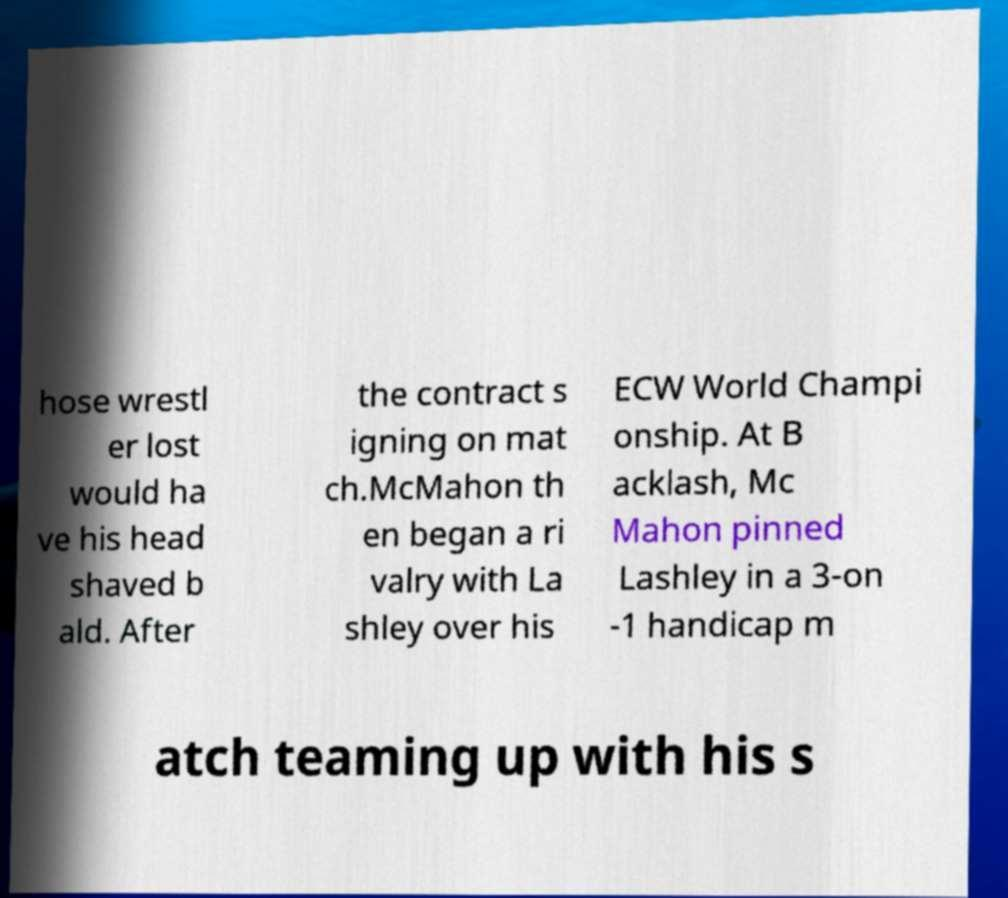Can you accurately transcribe the text from the provided image for me? hose wrestl er lost would ha ve his head shaved b ald. After the contract s igning on mat ch.McMahon th en began a ri valry with La shley over his ECW World Champi onship. At B acklash, Mc Mahon pinned Lashley in a 3-on -1 handicap m atch teaming up with his s 